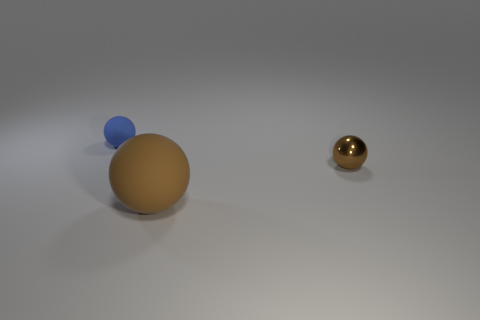Do the large sphere and the tiny metal sphere have the same color?
Make the answer very short. Yes. Are there any things that have the same color as the small shiny sphere?
Offer a very short reply. Yes. There is a rubber sphere in front of the blue sphere; is its color the same as the thing right of the brown matte ball?
Make the answer very short. Yes. What number of other objects are there of the same material as the large thing?
Offer a very short reply. 1. What number of tiny things are either blue things or brown objects?
Offer a very short reply. 2. Is the number of blue rubber spheres that are in front of the brown matte sphere the same as the number of tiny brown spheres?
Offer a very short reply. No. Are there any tiny brown shiny spheres that are behind the rubber ball to the right of the tiny blue matte ball?
Give a very brief answer. Yes. What number of other objects are the same color as the large rubber thing?
Your answer should be compact. 1. The big rubber object has what color?
Provide a short and direct response. Brown. There is a sphere that is both in front of the tiny blue matte sphere and left of the tiny brown metal object; what size is it?
Provide a short and direct response. Large. 